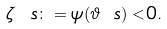Convert formula to latex. <formula><loc_0><loc_0><loc_500><loc_500>\zeta { \ s } \colon = \psi ( { \vartheta } { \ s } ) < 0 .</formula> 